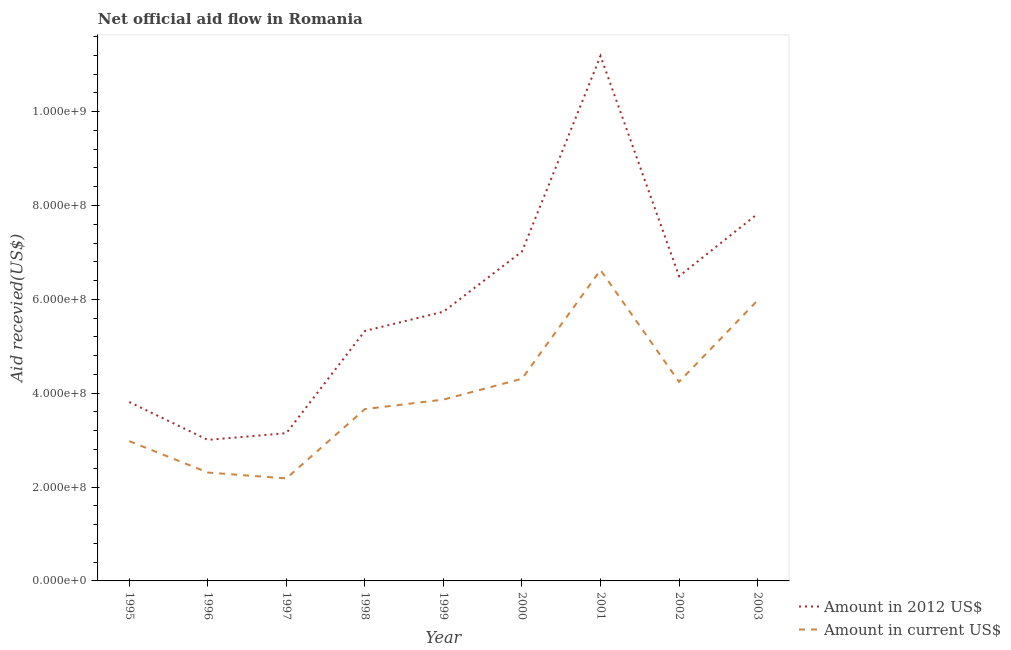How many different coloured lines are there?
Make the answer very short. 2. What is the amount of aid received(expressed in us$) in 2003?
Your response must be concise. 5.98e+08. Across all years, what is the maximum amount of aid received(expressed in 2012 us$)?
Your response must be concise. 1.12e+09. Across all years, what is the minimum amount of aid received(expressed in 2012 us$)?
Your response must be concise. 3.00e+08. In which year was the amount of aid received(expressed in us$) minimum?
Keep it short and to the point. 1997. What is the total amount of aid received(expressed in 2012 us$) in the graph?
Ensure brevity in your answer.  5.35e+09. What is the difference between the amount of aid received(expressed in 2012 us$) in 1996 and that in 1998?
Your response must be concise. -2.32e+08. What is the difference between the amount of aid received(expressed in us$) in 2002 and the amount of aid received(expressed in 2012 us$) in 1998?
Make the answer very short. -1.09e+08. What is the average amount of aid received(expressed in 2012 us$) per year?
Ensure brevity in your answer.  5.95e+08. In the year 1997, what is the difference between the amount of aid received(expressed in us$) and amount of aid received(expressed in 2012 us$)?
Give a very brief answer. -9.64e+07. In how many years, is the amount of aid received(expressed in us$) greater than 240000000 US$?
Your answer should be compact. 7. What is the ratio of the amount of aid received(expressed in 2012 us$) in 2001 to that in 2002?
Ensure brevity in your answer.  1.72. Is the amount of aid received(expressed in 2012 us$) in 1995 less than that in 1998?
Provide a short and direct response. Yes. What is the difference between the highest and the second highest amount of aid received(expressed in us$)?
Offer a very short reply. 6.46e+07. What is the difference between the highest and the lowest amount of aid received(expressed in 2012 us$)?
Provide a short and direct response. 8.18e+08. Is the amount of aid received(expressed in us$) strictly less than the amount of aid received(expressed in 2012 us$) over the years?
Ensure brevity in your answer.  Yes. What is the difference between two consecutive major ticks on the Y-axis?
Make the answer very short. 2.00e+08. Are the values on the major ticks of Y-axis written in scientific E-notation?
Give a very brief answer. Yes. Does the graph contain any zero values?
Give a very brief answer. No. Does the graph contain grids?
Offer a very short reply. No. Where does the legend appear in the graph?
Ensure brevity in your answer.  Bottom right. What is the title of the graph?
Offer a terse response. Net official aid flow in Romania. Does "Arms exports" appear as one of the legend labels in the graph?
Offer a terse response. No. What is the label or title of the Y-axis?
Offer a very short reply. Aid recevied(US$). What is the Aid recevied(US$) in Amount in 2012 US$ in 1995?
Offer a terse response. 3.81e+08. What is the Aid recevied(US$) in Amount in current US$ in 1995?
Your answer should be very brief. 2.98e+08. What is the Aid recevied(US$) of Amount in 2012 US$ in 1996?
Give a very brief answer. 3.00e+08. What is the Aid recevied(US$) of Amount in current US$ in 1996?
Your answer should be compact. 2.31e+08. What is the Aid recevied(US$) in Amount in 2012 US$ in 1997?
Your response must be concise. 3.15e+08. What is the Aid recevied(US$) of Amount in current US$ in 1997?
Provide a succinct answer. 2.18e+08. What is the Aid recevied(US$) in Amount in 2012 US$ in 1998?
Provide a short and direct response. 5.33e+08. What is the Aid recevied(US$) of Amount in current US$ in 1998?
Provide a succinct answer. 3.66e+08. What is the Aid recevied(US$) in Amount in 2012 US$ in 1999?
Your answer should be compact. 5.74e+08. What is the Aid recevied(US$) of Amount in current US$ in 1999?
Your answer should be compact. 3.86e+08. What is the Aid recevied(US$) in Amount in 2012 US$ in 2000?
Make the answer very short. 7.02e+08. What is the Aid recevied(US$) of Amount in current US$ in 2000?
Offer a very short reply. 4.31e+08. What is the Aid recevied(US$) in Amount in 2012 US$ in 2001?
Give a very brief answer. 1.12e+09. What is the Aid recevied(US$) of Amount in current US$ in 2001?
Provide a short and direct response. 6.62e+08. What is the Aid recevied(US$) in Amount in 2012 US$ in 2002?
Your response must be concise. 6.49e+08. What is the Aid recevied(US$) of Amount in current US$ in 2002?
Offer a very short reply. 4.24e+08. What is the Aid recevied(US$) in Amount in 2012 US$ in 2003?
Offer a terse response. 7.82e+08. What is the Aid recevied(US$) in Amount in current US$ in 2003?
Your answer should be compact. 5.98e+08. Across all years, what is the maximum Aid recevied(US$) in Amount in 2012 US$?
Ensure brevity in your answer.  1.12e+09. Across all years, what is the maximum Aid recevied(US$) of Amount in current US$?
Your response must be concise. 6.62e+08. Across all years, what is the minimum Aid recevied(US$) in Amount in 2012 US$?
Offer a very short reply. 3.00e+08. Across all years, what is the minimum Aid recevied(US$) of Amount in current US$?
Offer a terse response. 2.18e+08. What is the total Aid recevied(US$) of Amount in 2012 US$ in the graph?
Your response must be concise. 5.35e+09. What is the total Aid recevied(US$) in Amount in current US$ in the graph?
Ensure brevity in your answer.  3.61e+09. What is the difference between the Aid recevied(US$) of Amount in 2012 US$ in 1995 and that in 1996?
Offer a very short reply. 8.07e+07. What is the difference between the Aid recevied(US$) in Amount in current US$ in 1995 and that in 1996?
Give a very brief answer. 6.69e+07. What is the difference between the Aid recevied(US$) in Amount in 2012 US$ in 1995 and that in 1997?
Your response must be concise. 6.63e+07. What is the difference between the Aid recevied(US$) in Amount in current US$ in 1995 and that in 1997?
Provide a short and direct response. 7.94e+07. What is the difference between the Aid recevied(US$) in Amount in 2012 US$ in 1995 and that in 1998?
Your answer should be very brief. -1.52e+08. What is the difference between the Aid recevied(US$) in Amount in current US$ in 1995 and that in 1998?
Give a very brief answer. -6.83e+07. What is the difference between the Aid recevied(US$) of Amount in 2012 US$ in 1995 and that in 1999?
Offer a terse response. -1.92e+08. What is the difference between the Aid recevied(US$) in Amount in current US$ in 1995 and that in 1999?
Give a very brief answer. -8.85e+07. What is the difference between the Aid recevied(US$) of Amount in 2012 US$ in 1995 and that in 2000?
Make the answer very short. -3.21e+08. What is the difference between the Aid recevied(US$) in Amount in current US$ in 1995 and that in 2000?
Ensure brevity in your answer.  -1.33e+08. What is the difference between the Aid recevied(US$) in Amount in 2012 US$ in 1995 and that in 2001?
Ensure brevity in your answer.  -7.37e+08. What is the difference between the Aid recevied(US$) in Amount in current US$ in 1995 and that in 2001?
Offer a terse response. -3.65e+08. What is the difference between the Aid recevied(US$) of Amount in 2012 US$ in 1995 and that in 2002?
Your answer should be compact. -2.68e+08. What is the difference between the Aid recevied(US$) in Amount in current US$ in 1995 and that in 2002?
Your answer should be very brief. -1.26e+08. What is the difference between the Aid recevied(US$) of Amount in 2012 US$ in 1995 and that in 2003?
Your answer should be compact. -4.01e+08. What is the difference between the Aid recevied(US$) of Amount in current US$ in 1995 and that in 2003?
Keep it short and to the point. -3.00e+08. What is the difference between the Aid recevied(US$) of Amount in 2012 US$ in 1996 and that in 1997?
Make the answer very short. -1.44e+07. What is the difference between the Aid recevied(US$) of Amount in current US$ in 1996 and that in 1997?
Offer a terse response. 1.25e+07. What is the difference between the Aid recevied(US$) in Amount in 2012 US$ in 1996 and that in 1998?
Your answer should be very brief. -2.32e+08. What is the difference between the Aid recevied(US$) in Amount in current US$ in 1996 and that in 1998?
Provide a succinct answer. -1.35e+08. What is the difference between the Aid recevied(US$) in Amount in 2012 US$ in 1996 and that in 1999?
Offer a very short reply. -2.73e+08. What is the difference between the Aid recevied(US$) of Amount in current US$ in 1996 and that in 1999?
Offer a terse response. -1.55e+08. What is the difference between the Aid recevied(US$) in Amount in 2012 US$ in 1996 and that in 2000?
Provide a succinct answer. -4.01e+08. What is the difference between the Aid recevied(US$) of Amount in current US$ in 1996 and that in 2000?
Provide a short and direct response. -2.00e+08. What is the difference between the Aid recevied(US$) in Amount in 2012 US$ in 1996 and that in 2001?
Offer a very short reply. -8.18e+08. What is the difference between the Aid recevied(US$) of Amount in current US$ in 1996 and that in 2001?
Ensure brevity in your answer.  -4.31e+08. What is the difference between the Aid recevied(US$) of Amount in 2012 US$ in 1996 and that in 2002?
Offer a terse response. -3.49e+08. What is the difference between the Aid recevied(US$) of Amount in current US$ in 1996 and that in 2002?
Keep it short and to the point. -1.93e+08. What is the difference between the Aid recevied(US$) in Amount in 2012 US$ in 1996 and that in 2003?
Ensure brevity in your answer.  -4.82e+08. What is the difference between the Aid recevied(US$) of Amount in current US$ in 1996 and that in 2003?
Give a very brief answer. -3.67e+08. What is the difference between the Aid recevied(US$) of Amount in 2012 US$ in 1997 and that in 1998?
Offer a terse response. -2.18e+08. What is the difference between the Aid recevied(US$) in Amount in current US$ in 1997 and that in 1998?
Give a very brief answer. -1.48e+08. What is the difference between the Aid recevied(US$) of Amount in 2012 US$ in 1997 and that in 1999?
Keep it short and to the point. -2.59e+08. What is the difference between the Aid recevied(US$) in Amount in current US$ in 1997 and that in 1999?
Offer a terse response. -1.68e+08. What is the difference between the Aid recevied(US$) of Amount in 2012 US$ in 1997 and that in 2000?
Give a very brief answer. -3.87e+08. What is the difference between the Aid recevied(US$) of Amount in current US$ in 1997 and that in 2000?
Your answer should be compact. -2.12e+08. What is the difference between the Aid recevied(US$) in Amount in 2012 US$ in 1997 and that in 2001?
Give a very brief answer. -8.04e+08. What is the difference between the Aid recevied(US$) of Amount in current US$ in 1997 and that in 2001?
Your response must be concise. -4.44e+08. What is the difference between the Aid recevied(US$) of Amount in 2012 US$ in 1997 and that in 2002?
Ensure brevity in your answer.  -3.34e+08. What is the difference between the Aid recevied(US$) of Amount in current US$ in 1997 and that in 2002?
Keep it short and to the point. -2.06e+08. What is the difference between the Aid recevied(US$) of Amount in 2012 US$ in 1997 and that in 2003?
Your answer should be very brief. -4.67e+08. What is the difference between the Aid recevied(US$) of Amount in current US$ in 1997 and that in 2003?
Your response must be concise. -3.79e+08. What is the difference between the Aid recevied(US$) in Amount in 2012 US$ in 1998 and that in 1999?
Keep it short and to the point. -4.10e+07. What is the difference between the Aid recevied(US$) of Amount in current US$ in 1998 and that in 1999?
Offer a very short reply. -2.03e+07. What is the difference between the Aid recevied(US$) in Amount in 2012 US$ in 1998 and that in 2000?
Give a very brief answer. -1.69e+08. What is the difference between the Aid recevied(US$) in Amount in current US$ in 1998 and that in 2000?
Give a very brief answer. -6.46e+07. What is the difference between the Aid recevied(US$) in Amount in 2012 US$ in 1998 and that in 2001?
Your answer should be compact. -5.86e+08. What is the difference between the Aid recevied(US$) in Amount in current US$ in 1998 and that in 2001?
Provide a succinct answer. -2.96e+08. What is the difference between the Aid recevied(US$) of Amount in 2012 US$ in 1998 and that in 2002?
Give a very brief answer. -1.17e+08. What is the difference between the Aid recevied(US$) of Amount in current US$ in 1998 and that in 2002?
Ensure brevity in your answer.  -5.80e+07. What is the difference between the Aid recevied(US$) in Amount in 2012 US$ in 1998 and that in 2003?
Provide a succinct answer. -2.50e+08. What is the difference between the Aid recevied(US$) of Amount in current US$ in 1998 and that in 2003?
Make the answer very short. -2.32e+08. What is the difference between the Aid recevied(US$) of Amount in 2012 US$ in 1999 and that in 2000?
Keep it short and to the point. -1.28e+08. What is the difference between the Aid recevied(US$) of Amount in current US$ in 1999 and that in 2000?
Ensure brevity in your answer.  -4.44e+07. What is the difference between the Aid recevied(US$) in Amount in 2012 US$ in 1999 and that in 2001?
Make the answer very short. -5.45e+08. What is the difference between the Aid recevied(US$) of Amount in current US$ in 1999 and that in 2001?
Offer a terse response. -2.76e+08. What is the difference between the Aid recevied(US$) in Amount in 2012 US$ in 1999 and that in 2002?
Provide a short and direct response. -7.56e+07. What is the difference between the Aid recevied(US$) in Amount in current US$ in 1999 and that in 2002?
Make the answer very short. -3.78e+07. What is the difference between the Aid recevied(US$) in Amount in 2012 US$ in 1999 and that in 2003?
Provide a succinct answer. -2.09e+08. What is the difference between the Aid recevied(US$) of Amount in current US$ in 1999 and that in 2003?
Make the answer very short. -2.11e+08. What is the difference between the Aid recevied(US$) of Amount in 2012 US$ in 2000 and that in 2001?
Provide a succinct answer. -4.17e+08. What is the difference between the Aid recevied(US$) of Amount in current US$ in 2000 and that in 2001?
Provide a short and direct response. -2.32e+08. What is the difference between the Aid recevied(US$) of Amount in 2012 US$ in 2000 and that in 2002?
Offer a terse response. 5.26e+07. What is the difference between the Aid recevied(US$) in Amount in current US$ in 2000 and that in 2002?
Offer a very short reply. 6.62e+06. What is the difference between the Aid recevied(US$) of Amount in 2012 US$ in 2000 and that in 2003?
Your answer should be compact. -8.04e+07. What is the difference between the Aid recevied(US$) in Amount in current US$ in 2000 and that in 2003?
Offer a very short reply. -1.67e+08. What is the difference between the Aid recevied(US$) in Amount in 2012 US$ in 2001 and that in 2002?
Offer a terse response. 4.69e+08. What is the difference between the Aid recevied(US$) of Amount in current US$ in 2001 and that in 2002?
Provide a succinct answer. 2.38e+08. What is the difference between the Aid recevied(US$) in Amount in 2012 US$ in 2001 and that in 2003?
Ensure brevity in your answer.  3.36e+08. What is the difference between the Aid recevied(US$) in Amount in current US$ in 2001 and that in 2003?
Keep it short and to the point. 6.46e+07. What is the difference between the Aid recevied(US$) of Amount in 2012 US$ in 2002 and that in 2003?
Provide a succinct answer. -1.33e+08. What is the difference between the Aid recevied(US$) of Amount in current US$ in 2002 and that in 2003?
Your answer should be compact. -1.74e+08. What is the difference between the Aid recevied(US$) in Amount in 2012 US$ in 1995 and the Aid recevied(US$) in Amount in current US$ in 1996?
Provide a short and direct response. 1.50e+08. What is the difference between the Aid recevied(US$) in Amount in 2012 US$ in 1995 and the Aid recevied(US$) in Amount in current US$ in 1997?
Make the answer very short. 1.63e+08. What is the difference between the Aid recevied(US$) in Amount in 2012 US$ in 1995 and the Aid recevied(US$) in Amount in current US$ in 1998?
Your answer should be very brief. 1.50e+07. What is the difference between the Aid recevied(US$) of Amount in 2012 US$ in 1995 and the Aid recevied(US$) of Amount in current US$ in 1999?
Your answer should be compact. -5.23e+06. What is the difference between the Aid recevied(US$) of Amount in 2012 US$ in 1995 and the Aid recevied(US$) of Amount in current US$ in 2000?
Offer a terse response. -4.96e+07. What is the difference between the Aid recevied(US$) of Amount in 2012 US$ in 1995 and the Aid recevied(US$) of Amount in current US$ in 2001?
Provide a short and direct response. -2.81e+08. What is the difference between the Aid recevied(US$) in Amount in 2012 US$ in 1995 and the Aid recevied(US$) in Amount in current US$ in 2002?
Provide a short and direct response. -4.30e+07. What is the difference between the Aid recevied(US$) of Amount in 2012 US$ in 1995 and the Aid recevied(US$) of Amount in current US$ in 2003?
Give a very brief answer. -2.17e+08. What is the difference between the Aid recevied(US$) of Amount in 2012 US$ in 1996 and the Aid recevied(US$) of Amount in current US$ in 1997?
Your response must be concise. 8.20e+07. What is the difference between the Aid recevied(US$) in Amount in 2012 US$ in 1996 and the Aid recevied(US$) in Amount in current US$ in 1998?
Keep it short and to the point. -6.57e+07. What is the difference between the Aid recevied(US$) of Amount in 2012 US$ in 1996 and the Aid recevied(US$) of Amount in current US$ in 1999?
Your response must be concise. -8.59e+07. What is the difference between the Aid recevied(US$) in Amount in 2012 US$ in 1996 and the Aid recevied(US$) in Amount in current US$ in 2000?
Keep it short and to the point. -1.30e+08. What is the difference between the Aid recevied(US$) of Amount in 2012 US$ in 1996 and the Aid recevied(US$) of Amount in current US$ in 2001?
Provide a succinct answer. -3.62e+08. What is the difference between the Aid recevied(US$) in Amount in 2012 US$ in 1996 and the Aid recevied(US$) in Amount in current US$ in 2002?
Make the answer very short. -1.24e+08. What is the difference between the Aid recevied(US$) of Amount in 2012 US$ in 1996 and the Aid recevied(US$) of Amount in current US$ in 2003?
Keep it short and to the point. -2.97e+08. What is the difference between the Aid recevied(US$) of Amount in 2012 US$ in 1997 and the Aid recevied(US$) of Amount in current US$ in 1998?
Make the answer very short. -5.13e+07. What is the difference between the Aid recevied(US$) in Amount in 2012 US$ in 1997 and the Aid recevied(US$) in Amount in current US$ in 1999?
Make the answer very short. -7.15e+07. What is the difference between the Aid recevied(US$) in Amount in 2012 US$ in 1997 and the Aid recevied(US$) in Amount in current US$ in 2000?
Offer a terse response. -1.16e+08. What is the difference between the Aid recevied(US$) in Amount in 2012 US$ in 1997 and the Aid recevied(US$) in Amount in current US$ in 2001?
Provide a short and direct response. -3.48e+08. What is the difference between the Aid recevied(US$) in Amount in 2012 US$ in 1997 and the Aid recevied(US$) in Amount in current US$ in 2002?
Give a very brief answer. -1.09e+08. What is the difference between the Aid recevied(US$) of Amount in 2012 US$ in 1997 and the Aid recevied(US$) of Amount in current US$ in 2003?
Your answer should be compact. -2.83e+08. What is the difference between the Aid recevied(US$) in Amount in 2012 US$ in 1998 and the Aid recevied(US$) in Amount in current US$ in 1999?
Provide a short and direct response. 1.46e+08. What is the difference between the Aid recevied(US$) in Amount in 2012 US$ in 1998 and the Aid recevied(US$) in Amount in current US$ in 2000?
Your answer should be very brief. 1.02e+08. What is the difference between the Aid recevied(US$) of Amount in 2012 US$ in 1998 and the Aid recevied(US$) of Amount in current US$ in 2001?
Your answer should be very brief. -1.30e+08. What is the difference between the Aid recevied(US$) in Amount in 2012 US$ in 1998 and the Aid recevied(US$) in Amount in current US$ in 2002?
Your answer should be very brief. 1.09e+08. What is the difference between the Aid recevied(US$) in Amount in 2012 US$ in 1998 and the Aid recevied(US$) in Amount in current US$ in 2003?
Provide a short and direct response. -6.51e+07. What is the difference between the Aid recevied(US$) in Amount in 2012 US$ in 1999 and the Aid recevied(US$) in Amount in current US$ in 2000?
Provide a succinct answer. 1.43e+08. What is the difference between the Aid recevied(US$) in Amount in 2012 US$ in 1999 and the Aid recevied(US$) in Amount in current US$ in 2001?
Your response must be concise. -8.87e+07. What is the difference between the Aid recevied(US$) of Amount in 2012 US$ in 1999 and the Aid recevied(US$) of Amount in current US$ in 2002?
Your answer should be very brief. 1.49e+08. What is the difference between the Aid recevied(US$) of Amount in 2012 US$ in 1999 and the Aid recevied(US$) of Amount in current US$ in 2003?
Provide a succinct answer. -2.41e+07. What is the difference between the Aid recevied(US$) of Amount in 2012 US$ in 2000 and the Aid recevied(US$) of Amount in current US$ in 2001?
Provide a short and direct response. 3.95e+07. What is the difference between the Aid recevied(US$) in Amount in 2012 US$ in 2000 and the Aid recevied(US$) in Amount in current US$ in 2002?
Your answer should be compact. 2.78e+08. What is the difference between the Aid recevied(US$) of Amount in 2012 US$ in 2000 and the Aid recevied(US$) of Amount in current US$ in 2003?
Your response must be concise. 1.04e+08. What is the difference between the Aid recevied(US$) in Amount in 2012 US$ in 2001 and the Aid recevied(US$) in Amount in current US$ in 2002?
Ensure brevity in your answer.  6.94e+08. What is the difference between the Aid recevied(US$) of Amount in 2012 US$ in 2001 and the Aid recevied(US$) of Amount in current US$ in 2003?
Your answer should be compact. 5.21e+08. What is the difference between the Aid recevied(US$) in Amount in 2012 US$ in 2002 and the Aid recevied(US$) in Amount in current US$ in 2003?
Keep it short and to the point. 5.15e+07. What is the average Aid recevied(US$) of Amount in 2012 US$ per year?
Ensure brevity in your answer.  5.95e+08. What is the average Aid recevied(US$) of Amount in current US$ per year?
Ensure brevity in your answer.  4.02e+08. In the year 1995, what is the difference between the Aid recevied(US$) of Amount in 2012 US$ and Aid recevied(US$) of Amount in current US$?
Give a very brief answer. 8.33e+07. In the year 1996, what is the difference between the Aid recevied(US$) of Amount in 2012 US$ and Aid recevied(US$) of Amount in current US$?
Give a very brief answer. 6.95e+07. In the year 1997, what is the difference between the Aid recevied(US$) of Amount in 2012 US$ and Aid recevied(US$) of Amount in current US$?
Keep it short and to the point. 9.64e+07. In the year 1998, what is the difference between the Aid recevied(US$) in Amount in 2012 US$ and Aid recevied(US$) in Amount in current US$?
Ensure brevity in your answer.  1.67e+08. In the year 1999, what is the difference between the Aid recevied(US$) of Amount in 2012 US$ and Aid recevied(US$) of Amount in current US$?
Offer a terse response. 1.87e+08. In the year 2000, what is the difference between the Aid recevied(US$) in Amount in 2012 US$ and Aid recevied(US$) in Amount in current US$?
Offer a terse response. 2.71e+08. In the year 2001, what is the difference between the Aid recevied(US$) of Amount in 2012 US$ and Aid recevied(US$) of Amount in current US$?
Offer a terse response. 4.56e+08. In the year 2002, what is the difference between the Aid recevied(US$) in Amount in 2012 US$ and Aid recevied(US$) in Amount in current US$?
Your answer should be very brief. 2.25e+08. In the year 2003, what is the difference between the Aid recevied(US$) in Amount in 2012 US$ and Aid recevied(US$) in Amount in current US$?
Your answer should be very brief. 1.85e+08. What is the ratio of the Aid recevied(US$) in Amount in 2012 US$ in 1995 to that in 1996?
Offer a terse response. 1.27. What is the ratio of the Aid recevied(US$) in Amount in current US$ in 1995 to that in 1996?
Your response must be concise. 1.29. What is the ratio of the Aid recevied(US$) of Amount in 2012 US$ in 1995 to that in 1997?
Give a very brief answer. 1.21. What is the ratio of the Aid recevied(US$) of Amount in current US$ in 1995 to that in 1997?
Provide a short and direct response. 1.36. What is the ratio of the Aid recevied(US$) in Amount in 2012 US$ in 1995 to that in 1998?
Offer a terse response. 0.72. What is the ratio of the Aid recevied(US$) in Amount in current US$ in 1995 to that in 1998?
Your answer should be very brief. 0.81. What is the ratio of the Aid recevied(US$) in Amount in 2012 US$ in 1995 to that in 1999?
Provide a short and direct response. 0.66. What is the ratio of the Aid recevied(US$) of Amount in current US$ in 1995 to that in 1999?
Ensure brevity in your answer.  0.77. What is the ratio of the Aid recevied(US$) in Amount in 2012 US$ in 1995 to that in 2000?
Your answer should be compact. 0.54. What is the ratio of the Aid recevied(US$) in Amount in current US$ in 1995 to that in 2000?
Provide a succinct answer. 0.69. What is the ratio of the Aid recevied(US$) of Amount in 2012 US$ in 1995 to that in 2001?
Your answer should be compact. 0.34. What is the ratio of the Aid recevied(US$) of Amount in current US$ in 1995 to that in 2001?
Ensure brevity in your answer.  0.45. What is the ratio of the Aid recevied(US$) in Amount in 2012 US$ in 1995 to that in 2002?
Your answer should be compact. 0.59. What is the ratio of the Aid recevied(US$) in Amount in current US$ in 1995 to that in 2002?
Ensure brevity in your answer.  0.7. What is the ratio of the Aid recevied(US$) of Amount in 2012 US$ in 1995 to that in 2003?
Offer a very short reply. 0.49. What is the ratio of the Aid recevied(US$) of Amount in current US$ in 1995 to that in 2003?
Offer a terse response. 0.5. What is the ratio of the Aid recevied(US$) in Amount in 2012 US$ in 1996 to that in 1997?
Offer a very short reply. 0.95. What is the ratio of the Aid recevied(US$) of Amount in current US$ in 1996 to that in 1997?
Provide a succinct answer. 1.06. What is the ratio of the Aid recevied(US$) of Amount in 2012 US$ in 1996 to that in 1998?
Your response must be concise. 0.56. What is the ratio of the Aid recevied(US$) of Amount in current US$ in 1996 to that in 1998?
Offer a very short reply. 0.63. What is the ratio of the Aid recevied(US$) of Amount in 2012 US$ in 1996 to that in 1999?
Ensure brevity in your answer.  0.52. What is the ratio of the Aid recevied(US$) in Amount in current US$ in 1996 to that in 1999?
Provide a short and direct response. 0.6. What is the ratio of the Aid recevied(US$) in Amount in 2012 US$ in 1996 to that in 2000?
Offer a very short reply. 0.43. What is the ratio of the Aid recevied(US$) of Amount in current US$ in 1996 to that in 2000?
Provide a short and direct response. 0.54. What is the ratio of the Aid recevied(US$) of Amount in 2012 US$ in 1996 to that in 2001?
Your answer should be very brief. 0.27. What is the ratio of the Aid recevied(US$) of Amount in current US$ in 1996 to that in 2001?
Offer a terse response. 0.35. What is the ratio of the Aid recevied(US$) of Amount in 2012 US$ in 1996 to that in 2002?
Provide a short and direct response. 0.46. What is the ratio of the Aid recevied(US$) of Amount in current US$ in 1996 to that in 2002?
Your answer should be compact. 0.54. What is the ratio of the Aid recevied(US$) in Amount in 2012 US$ in 1996 to that in 2003?
Keep it short and to the point. 0.38. What is the ratio of the Aid recevied(US$) of Amount in current US$ in 1996 to that in 2003?
Your answer should be compact. 0.39. What is the ratio of the Aid recevied(US$) in Amount in 2012 US$ in 1997 to that in 1998?
Your response must be concise. 0.59. What is the ratio of the Aid recevied(US$) in Amount in current US$ in 1997 to that in 1998?
Provide a succinct answer. 0.6. What is the ratio of the Aid recevied(US$) of Amount in 2012 US$ in 1997 to that in 1999?
Provide a succinct answer. 0.55. What is the ratio of the Aid recevied(US$) of Amount in current US$ in 1997 to that in 1999?
Your answer should be very brief. 0.57. What is the ratio of the Aid recevied(US$) in Amount in 2012 US$ in 1997 to that in 2000?
Your answer should be compact. 0.45. What is the ratio of the Aid recevied(US$) in Amount in current US$ in 1997 to that in 2000?
Provide a succinct answer. 0.51. What is the ratio of the Aid recevied(US$) of Amount in 2012 US$ in 1997 to that in 2001?
Offer a very short reply. 0.28. What is the ratio of the Aid recevied(US$) of Amount in current US$ in 1997 to that in 2001?
Provide a short and direct response. 0.33. What is the ratio of the Aid recevied(US$) in Amount in 2012 US$ in 1997 to that in 2002?
Give a very brief answer. 0.48. What is the ratio of the Aid recevied(US$) of Amount in current US$ in 1997 to that in 2002?
Keep it short and to the point. 0.52. What is the ratio of the Aid recevied(US$) of Amount in 2012 US$ in 1997 to that in 2003?
Give a very brief answer. 0.4. What is the ratio of the Aid recevied(US$) of Amount in current US$ in 1997 to that in 2003?
Your response must be concise. 0.37. What is the ratio of the Aid recevied(US$) in Amount in 2012 US$ in 1998 to that in 1999?
Provide a succinct answer. 0.93. What is the ratio of the Aid recevied(US$) of Amount in current US$ in 1998 to that in 1999?
Make the answer very short. 0.95. What is the ratio of the Aid recevied(US$) of Amount in 2012 US$ in 1998 to that in 2000?
Give a very brief answer. 0.76. What is the ratio of the Aid recevied(US$) in Amount in current US$ in 1998 to that in 2000?
Your answer should be very brief. 0.85. What is the ratio of the Aid recevied(US$) of Amount in 2012 US$ in 1998 to that in 2001?
Keep it short and to the point. 0.48. What is the ratio of the Aid recevied(US$) in Amount in current US$ in 1998 to that in 2001?
Your answer should be very brief. 0.55. What is the ratio of the Aid recevied(US$) in Amount in 2012 US$ in 1998 to that in 2002?
Keep it short and to the point. 0.82. What is the ratio of the Aid recevied(US$) of Amount in current US$ in 1998 to that in 2002?
Provide a short and direct response. 0.86. What is the ratio of the Aid recevied(US$) of Amount in 2012 US$ in 1998 to that in 2003?
Offer a terse response. 0.68. What is the ratio of the Aid recevied(US$) of Amount in current US$ in 1998 to that in 2003?
Provide a succinct answer. 0.61. What is the ratio of the Aid recevied(US$) in Amount in 2012 US$ in 1999 to that in 2000?
Provide a succinct answer. 0.82. What is the ratio of the Aid recevied(US$) of Amount in current US$ in 1999 to that in 2000?
Provide a short and direct response. 0.9. What is the ratio of the Aid recevied(US$) in Amount in 2012 US$ in 1999 to that in 2001?
Offer a terse response. 0.51. What is the ratio of the Aid recevied(US$) in Amount in current US$ in 1999 to that in 2001?
Your response must be concise. 0.58. What is the ratio of the Aid recevied(US$) of Amount in 2012 US$ in 1999 to that in 2002?
Make the answer very short. 0.88. What is the ratio of the Aid recevied(US$) of Amount in current US$ in 1999 to that in 2002?
Your response must be concise. 0.91. What is the ratio of the Aid recevied(US$) of Amount in 2012 US$ in 1999 to that in 2003?
Provide a short and direct response. 0.73. What is the ratio of the Aid recevied(US$) of Amount in current US$ in 1999 to that in 2003?
Your response must be concise. 0.65. What is the ratio of the Aid recevied(US$) of Amount in 2012 US$ in 2000 to that in 2001?
Keep it short and to the point. 0.63. What is the ratio of the Aid recevied(US$) in Amount in current US$ in 2000 to that in 2001?
Your response must be concise. 0.65. What is the ratio of the Aid recevied(US$) of Amount in 2012 US$ in 2000 to that in 2002?
Make the answer very short. 1.08. What is the ratio of the Aid recevied(US$) in Amount in current US$ in 2000 to that in 2002?
Provide a succinct answer. 1.02. What is the ratio of the Aid recevied(US$) of Amount in 2012 US$ in 2000 to that in 2003?
Your answer should be compact. 0.9. What is the ratio of the Aid recevied(US$) in Amount in current US$ in 2000 to that in 2003?
Your response must be concise. 0.72. What is the ratio of the Aid recevied(US$) in Amount in 2012 US$ in 2001 to that in 2002?
Your response must be concise. 1.72. What is the ratio of the Aid recevied(US$) of Amount in current US$ in 2001 to that in 2002?
Give a very brief answer. 1.56. What is the ratio of the Aid recevied(US$) in Amount in 2012 US$ in 2001 to that in 2003?
Give a very brief answer. 1.43. What is the ratio of the Aid recevied(US$) of Amount in current US$ in 2001 to that in 2003?
Offer a very short reply. 1.11. What is the ratio of the Aid recevied(US$) of Amount in 2012 US$ in 2002 to that in 2003?
Give a very brief answer. 0.83. What is the ratio of the Aid recevied(US$) in Amount in current US$ in 2002 to that in 2003?
Offer a terse response. 0.71. What is the difference between the highest and the second highest Aid recevied(US$) of Amount in 2012 US$?
Your answer should be compact. 3.36e+08. What is the difference between the highest and the second highest Aid recevied(US$) of Amount in current US$?
Offer a terse response. 6.46e+07. What is the difference between the highest and the lowest Aid recevied(US$) of Amount in 2012 US$?
Your response must be concise. 8.18e+08. What is the difference between the highest and the lowest Aid recevied(US$) of Amount in current US$?
Your answer should be compact. 4.44e+08. 